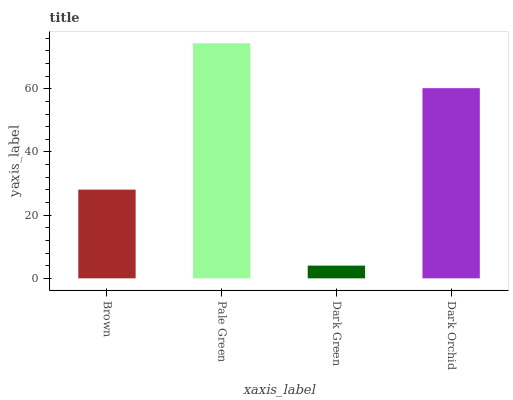Is Dark Green the minimum?
Answer yes or no. Yes. Is Pale Green the maximum?
Answer yes or no. Yes. Is Pale Green the minimum?
Answer yes or no. No. Is Dark Green the maximum?
Answer yes or no. No. Is Pale Green greater than Dark Green?
Answer yes or no. Yes. Is Dark Green less than Pale Green?
Answer yes or no. Yes. Is Dark Green greater than Pale Green?
Answer yes or no. No. Is Pale Green less than Dark Green?
Answer yes or no. No. Is Dark Orchid the high median?
Answer yes or no. Yes. Is Brown the low median?
Answer yes or no. Yes. Is Brown the high median?
Answer yes or no. No. Is Dark Green the low median?
Answer yes or no. No. 